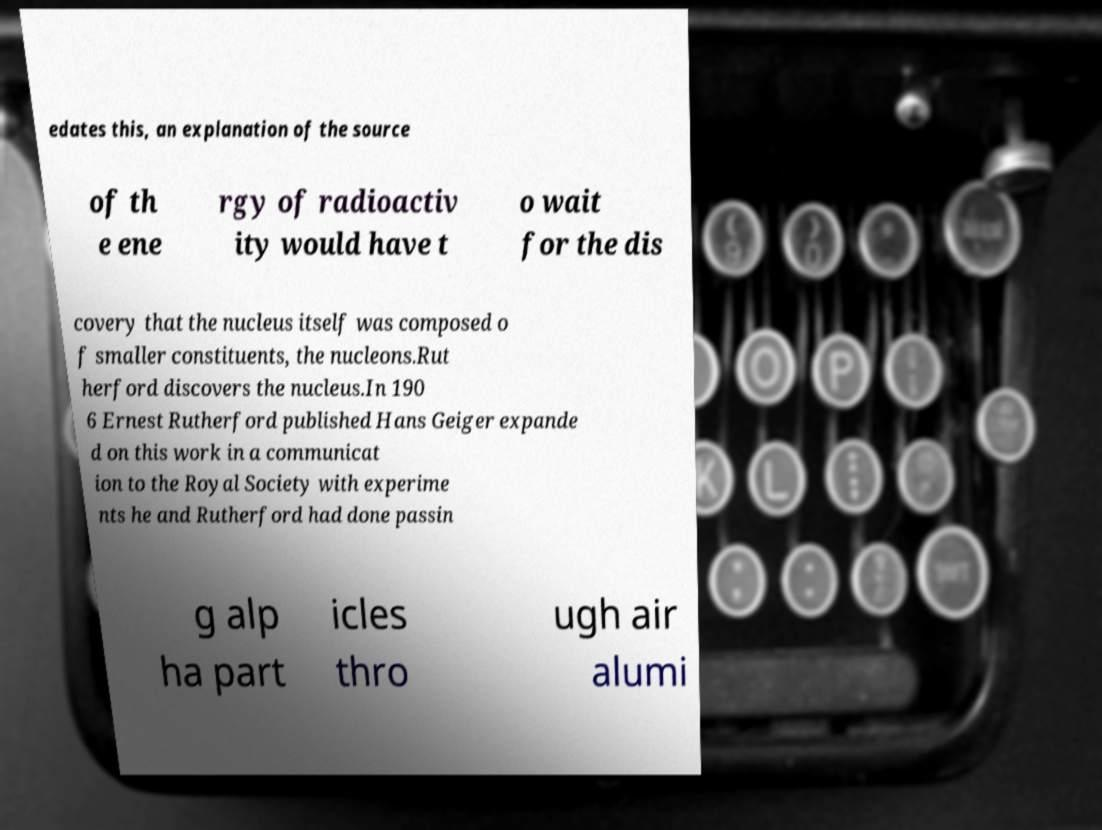There's text embedded in this image that I need extracted. Can you transcribe it verbatim? edates this, an explanation of the source of th e ene rgy of radioactiv ity would have t o wait for the dis covery that the nucleus itself was composed o f smaller constituents, the nucleons.Rut herford discovers the nucleus.In 190 6 Ernest Rutherford published Hans Geiger expande d on this work in a communicat ion to the Royal Society with experime nts he and Rutherford had done passin g alp ha part icles thro ugh air alumi 